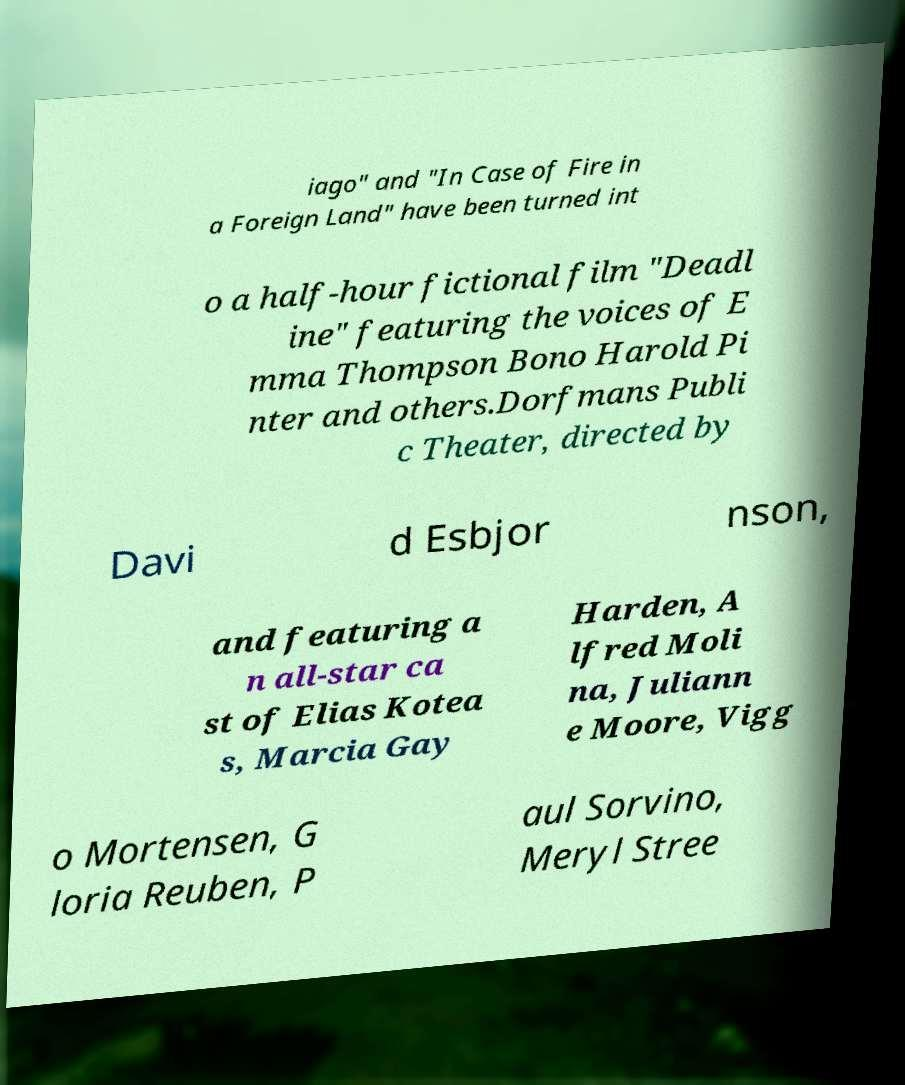There's text embedded in this image that I need extracted. Can you transcribe it verbatim? iago" and "In Case of Fire in a Foreign Land" have been turned int o a half-hour fictional film "Deadl ine" featuring the voices of E mma Thompson Bono Harold Pi nter and others.Dorfmans Publi c Theater, directed by Davi d Esbjor nson, and featuring a n all-star ca st of Elias Kotea s, Marcia Gay Harden, A lfred Moli na, Juliann e Moore, Vigg o Mortensen, G loria Reuben, P aul Sorvino, Meryl Stree 